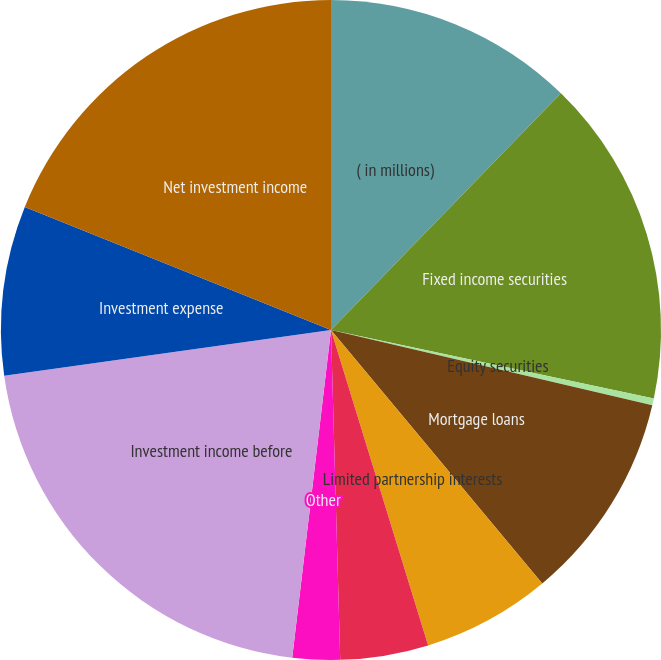Convert chart. <chart><loc_0><loc_0><loc_500><loc_500><pie_chart><fcel>( in millions)<fcel>Fixed income securities<fcel>Equity securities<fcel>Mortgage loans<fcel>Limited partnership interests<fcel>Short-term investments<fcel>Other<fcel>Investment income before<fcel>Investment expense<fcel>Net investment income<nl><fcel>12.27%<fcel>16.05%<fcel>0.34%<fcel>10.28%<fcel>6.3%<fcel>4.31%<fcel>2.32%<fcel>20.91%<fcel>8.29%<fcel>18.92%<nl></chart> 